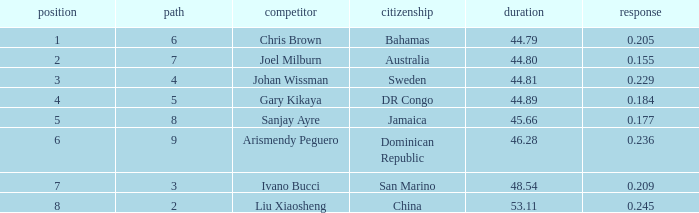What is the total average for Rank entries where the Lane listed is smaller than 4 and the Nationality listed is San Marino? 7.0. 